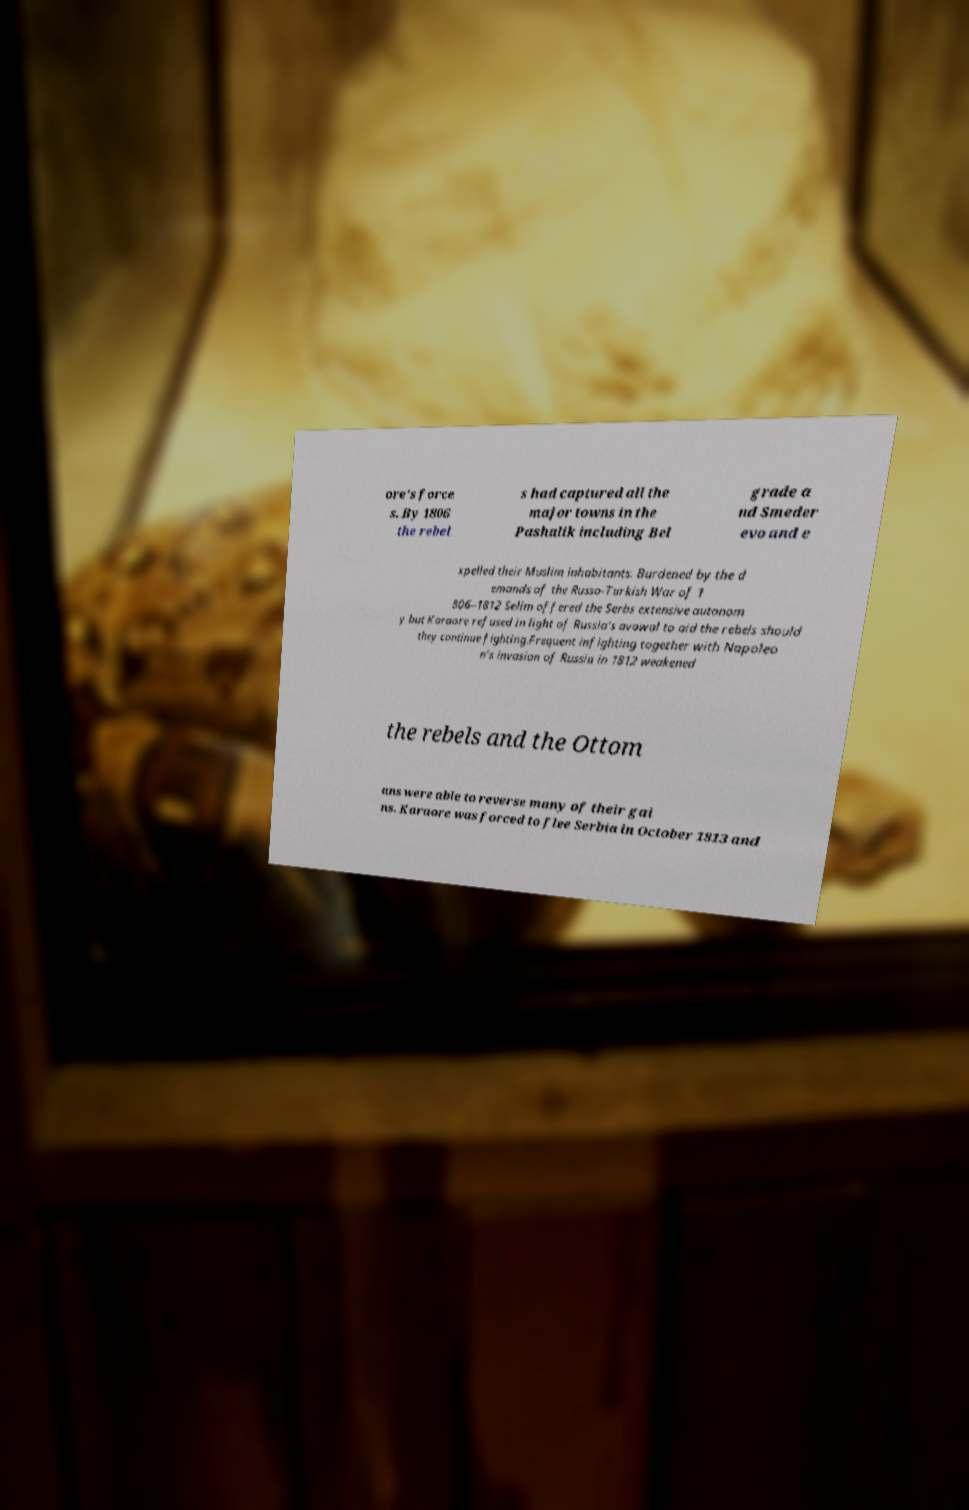Can you accurately transcribe the text from the provided image for me? ore's force s. By 1806 the rebel s had captured all the major towns in the Pashalik including Bel grade a nd Smeder evo and e xpelled their Muslim inhabitants. Burdened by the d emands of the Russo-Turkish War of 1 806–1812 Selim offered the Serbs extensive autonom y but Karaore refused in light of Russia's avowal to aid the rebels should they continue fighting.Frequent infighting together with Napoleo n's invasion of Russia in 1812 weakened the rebels and the Ottom ans were able to reverse many of their gai ns. Karaore was forced to flee Serbia in October 1813 and 